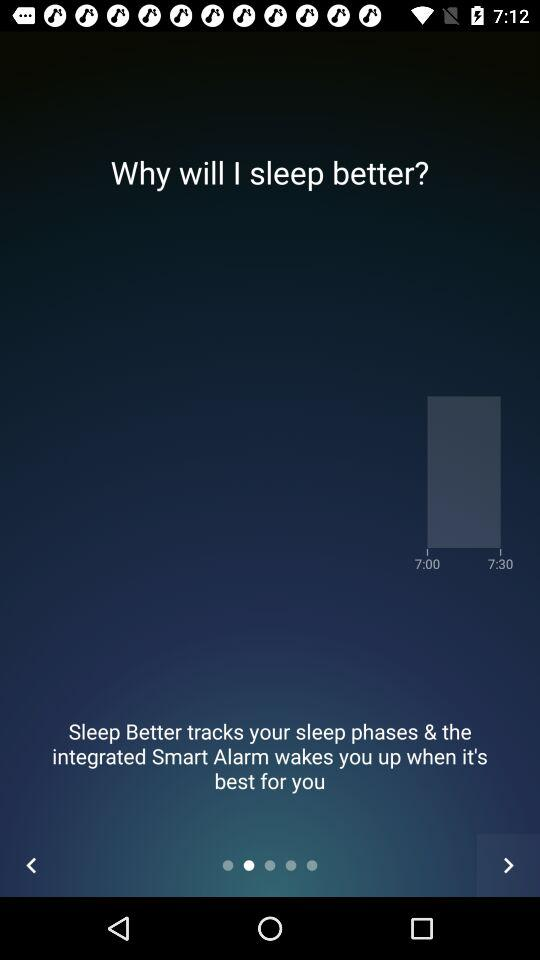What is the name of the application? The application name is "Sleep Better". 